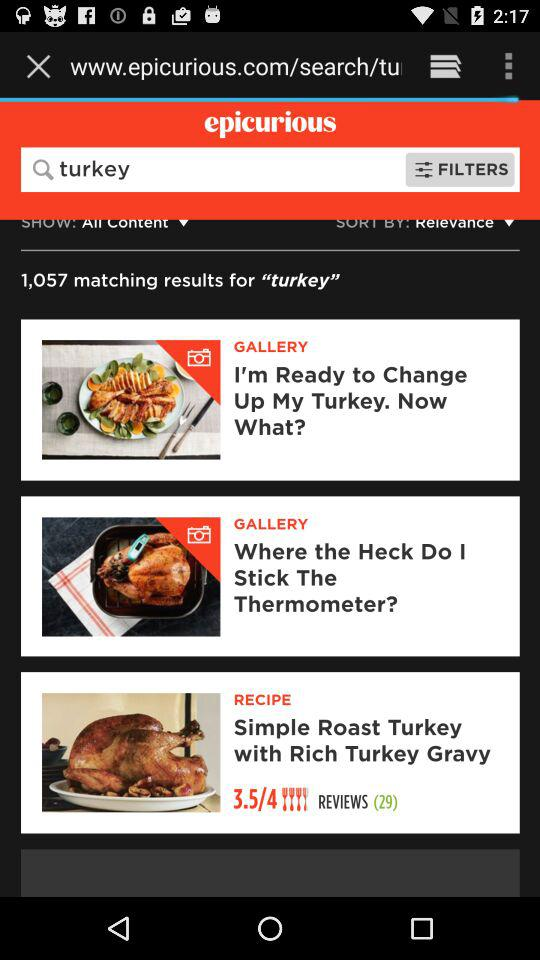How many reviews are there for the recipe "Simple Roast Turkey with Rich Turkey Gravy"?
Answer the question using a single word or phrase. 29 